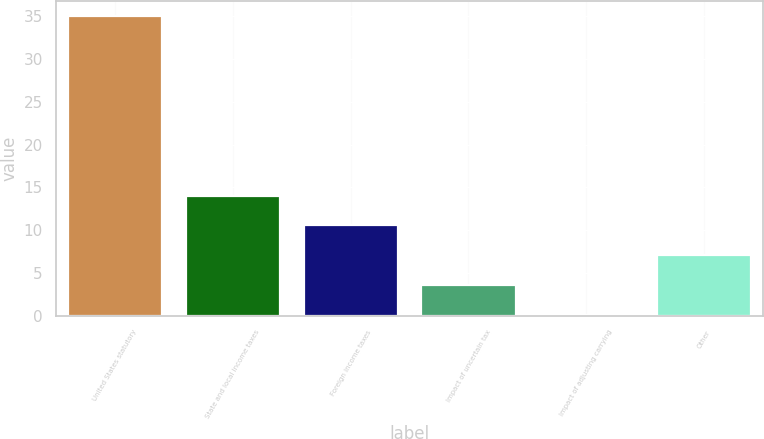Convert chart. <chart><loc_0><loc_0><loc_500><loc_500><bar_chart><fcel>United States statutory<fcel>State and local income taxes<fcel>Foreign income taxes<fcel>Impact of uncertain tax<fcel>Impact of adjusting carrying<fcel>Other<nl><fcel>35<fcel>14.04<fcel>10.55<fcel>3.57<fcel>0.08<fcel>7.06<nl></chart> 